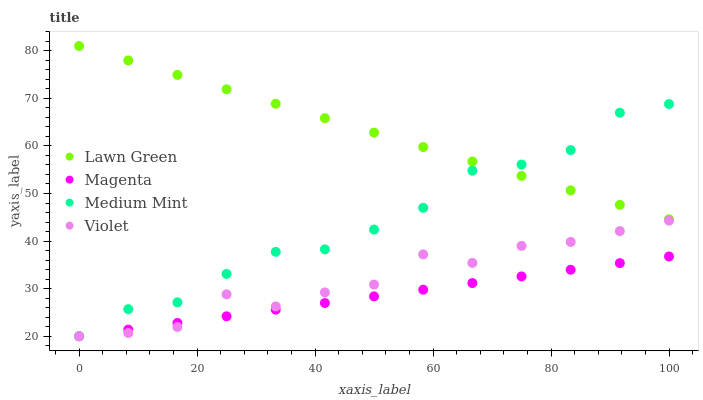Does Magenta have the minimum area under the curve?
Answer yes or no. Yes. Does Lawn Green have the maximum area under the curve?
Answer yes or no. Yes. Does Lawn Green have the minimum area under the curve?
Answer yes or no. No. Does Magenta have the maximum area under the curve?
Answer yes or no. No. Is Magenta the smoothest?
Answer yes or no. Yes. Is Violet the roughest?
Answer yes or no. Yes. Is Lawn Green the smoothest?
Answer yes or no. No. Is Lawn Green the roughest?
Answer yes or no. No. Does Magenta have the lowest value?
Answer yes or no. Yes. Does Lawn Green have the lowest value?
Answer yes or no. No. Does Lawn Green have the highest value?
Answer yes or no. Yes. Does Magenta have the highest value?
Answer yes or no. No. Is Magenta less than Medium Mint?
Answer yes or no. Yes. Is Lawn Green greater than Magenta?
Answer yes or no. Yes. Does Lawn Green intersect Medium Mint?
Answer yes or no. Yes. Is Lawn Green less than Medium Mint?
Answer yes or no. No. Is Lawn Green greater than Medium Mint?
Answer yes or no. No. Does Magenta intersect Medium Mint?
Answer yes or no. No. 